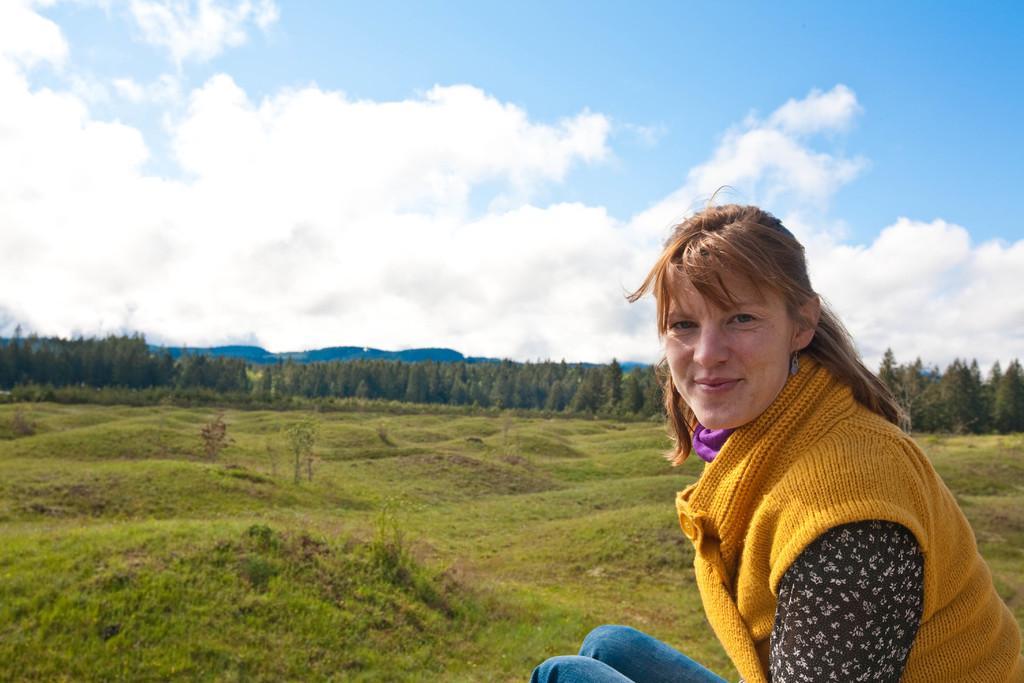Please provide a concise description of this image. In this image, we can see a lady. We can see the ground covered with grass. There are a few trees. We can see the sky with clouds. 